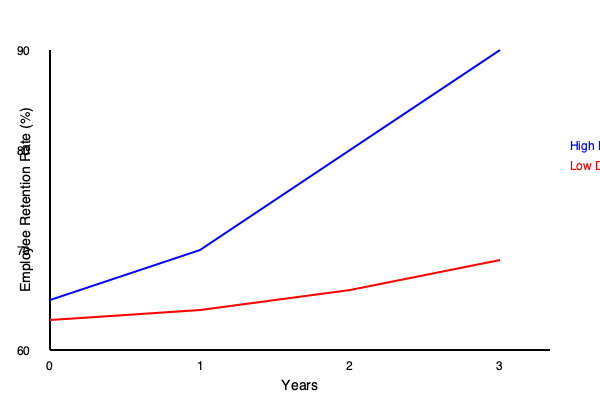Based on the line graph, what conclusion can be drawn about the relationship between employee retention rates and diversity levels in companies over a 3-year period? To answer this question, we need to analyze the trends shown in the graph:

1. The blue line represents companies with high diversity, while the red line represents companies with low diversity.

2. For high-diversity companies:
   - Starting point (Year 0): approximately 68% retention rate
   - Ending point (Year 3): approximately 88% retention rate
   - Overall trend: Steadily increasing

3. For low-diversity companies:
   - Starting point (Year 0): approximately 66% retention rate
   - Ending point (Year 3): approximately 72% retention rate
   - Overall trend: Slight increase, but much less pronounced

4. Comparing the two lines:
   - Both start at similar points (66-68% range)
   - The gap between them widens significantly over time
   - By Year 3, there's a substantial difference (approximately 16 percentage points)

5. Key observation:
   Companies with high diversity show a much steeper increase in employee retention rates compared to those with low diversity.

Given this analysis, we can conclude that there is a positive correlation between higher levels of diversity and improved employee retention rates over time.
Answer: Higher diversity correlates with improved employee retention rates over time. 